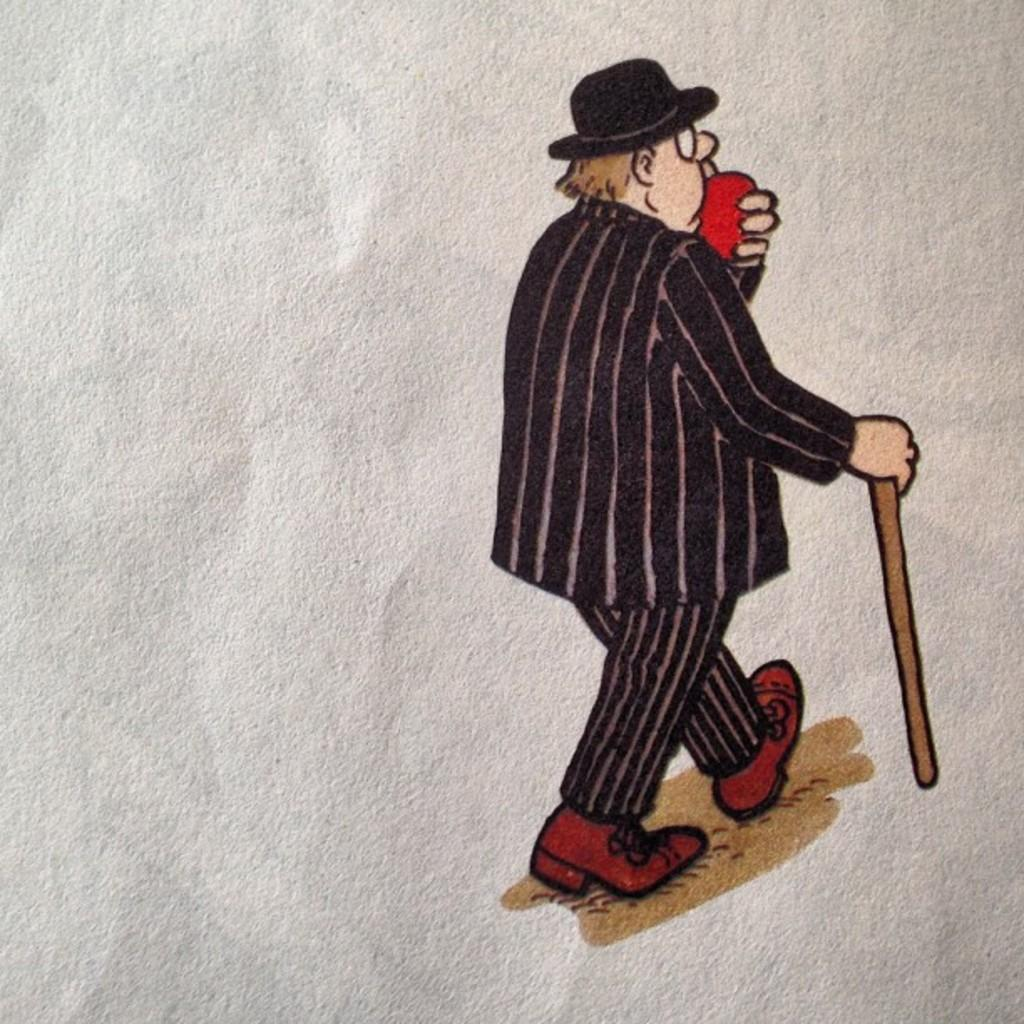What is the main subject of the image? There is a painting in the image. What does the painting depict? The painting represents a man. What type of competition is the man participating in within the painting? There is no competition depicted in the painting; it simply represents a man. 